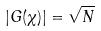<formula> <loc_0><loc_0><loc_500><loc_500>| G ( \chi ) | = \sqrt { N }</formula> 